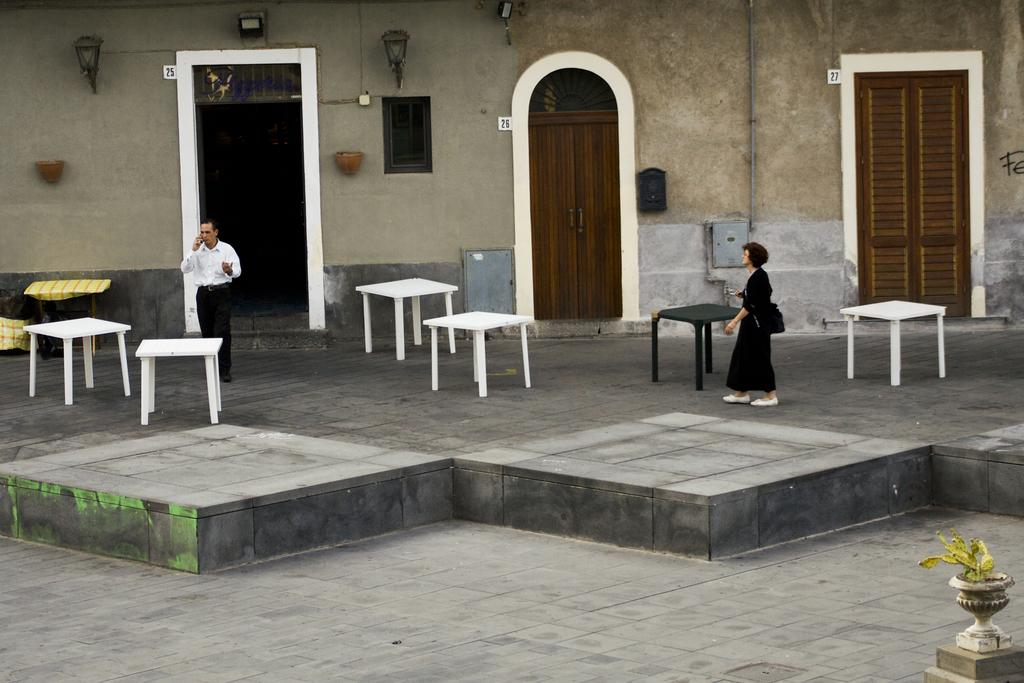How many people are present in the image? There are two persons standing in the image. What is the surface on which the persons are standing? The persons are standing on the floor. What type of furniture can be seen in the image? There are tables in the image. What architectural elements are visible in the image? There is a door and a wall in the image. What type of stocking is hanging on the door in the image? There is no stocking hanging on the door in the image. How much debt is visible in the image? There is no indication of debt in the image. 